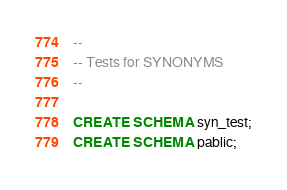<code> <loc_0><loc_0><loc_500><loc_500><_SQL_>--
-- Tests for SYNONYMS
--

CREATE SCHEMA syn_test;
CREATE SCHEMA pablic;</code> 